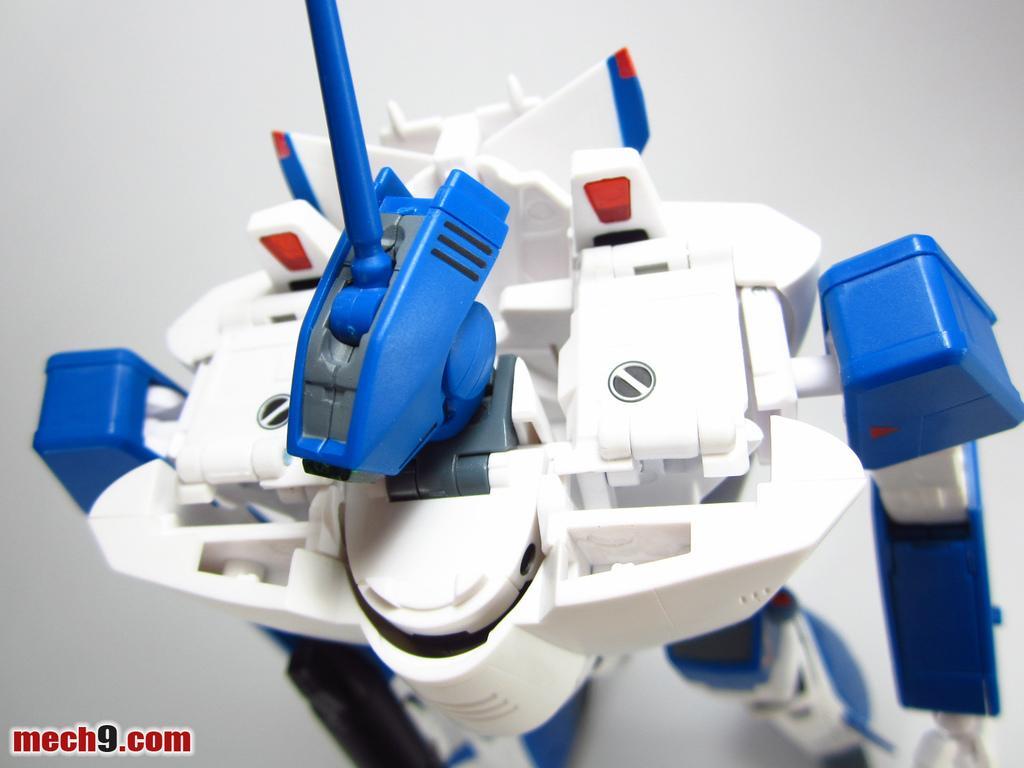Can you describe this image briefly? In the image we can see there is a robot toy. 